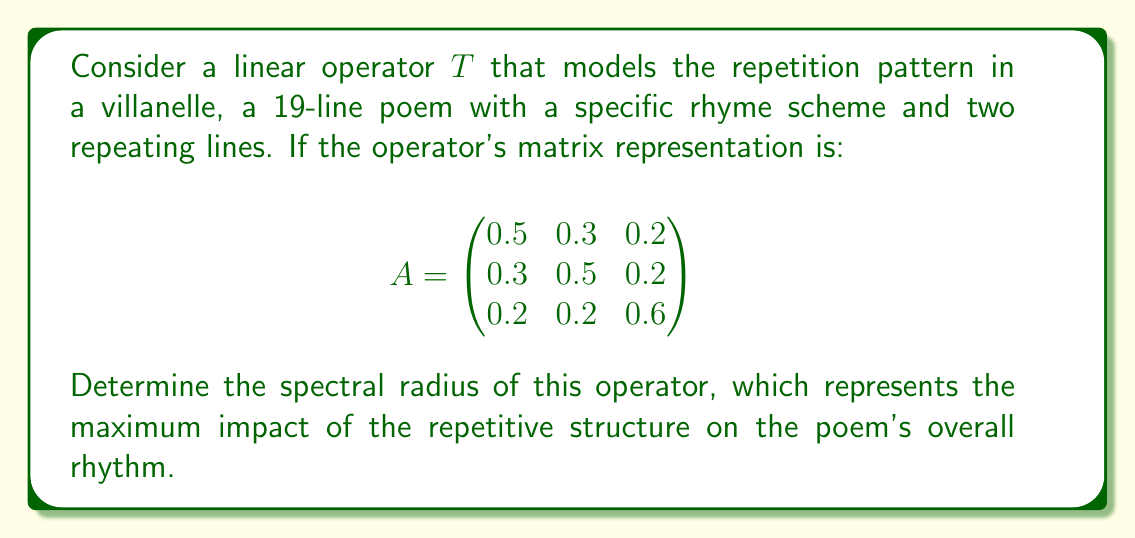Give your solution to this math problem. To find the spectral radius of the linear operator $T$, we need to follow these steps:

1) The spectral radius is the maximum absolute value of the eigenvalues of the operator.

2) To find the eigenvalues, we need to solve the characteristic equation:
   $$\det(A - \lambda I) = 0$$

3) Expanding this determinant:
   $$\begin{vmatrix}
   0.5-\lambda & 0.3 & 0.2 \\
   0.3 & 0.5-\lambda & 0.2 \\
   0.2 & 0.2 & 0.6-\lambda
   \end{vmatrix} = 0$$

4) This gives us the characteristic polynomial:
   $$-\lambda^3 + 1.6\lambda^2 - 0.71\lambda + 0.088 = 0$$

5) Using the cubic formula or numerical methods, we can find the roots of this polynomial. The eigenvalues are approximately:
   $$\lambda_1 \approx 1.0$$
   $$\lambda_2 \approx 0.3$$
   $$\lambda_3 \approx 0.3$$

6) The spectral radius is the maximum absolute value of these eigenvalues:
   $$\rho(T) = \max\{|\lambda_1|, |\lambda_2|, |\lambda_3|\} = \max\{1.0, 0.3, 0.3\} = 1.0$$

Therefore, the spectral radius of the operator $T$ is 1.0.
Answer: 1.0 